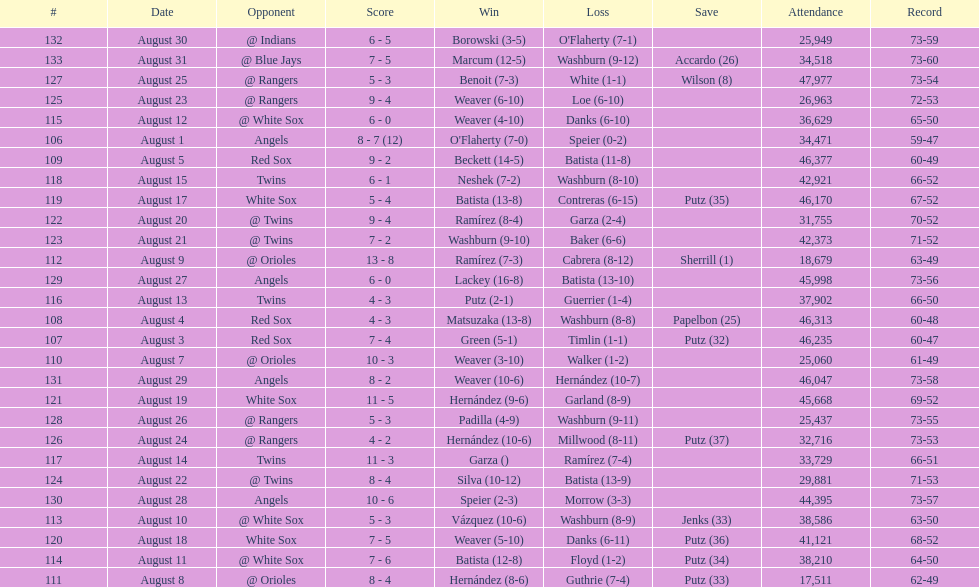How many losses during stretch? 7. 